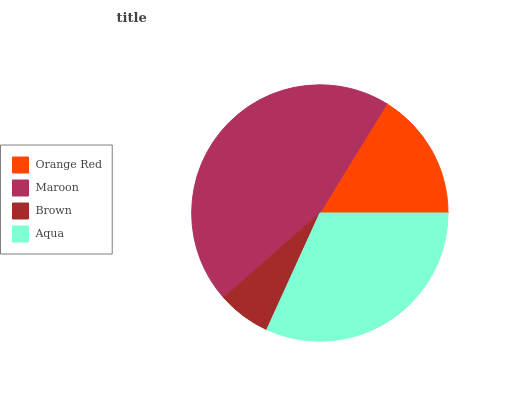Is Brown the minimum?
Answer yes or no. Yes. Is Maroon the maximum?
Answer yes or no. Yes. Is Maroon the minimum?
Answer yes or no. No. Is Brown the maximum?
Answer yes or no. No. Is Maroon greater than Brown?
Answer yes or no. Yes. Is Brown less than Maroon?
Answer yes or no. Yes. Is Brown greater than Maroon?
Answer yes or no. No. Is Maroon less than Brown?
Answer yes or no. No. Is Aqua the high median?
Answer yes or no. Yes. Is Orange Red the low median?
Answer yes or no. Yes. Is Brown the high median?
Answer yes or no. No. Is Maroon the low median?
Answer yes or no. No. 